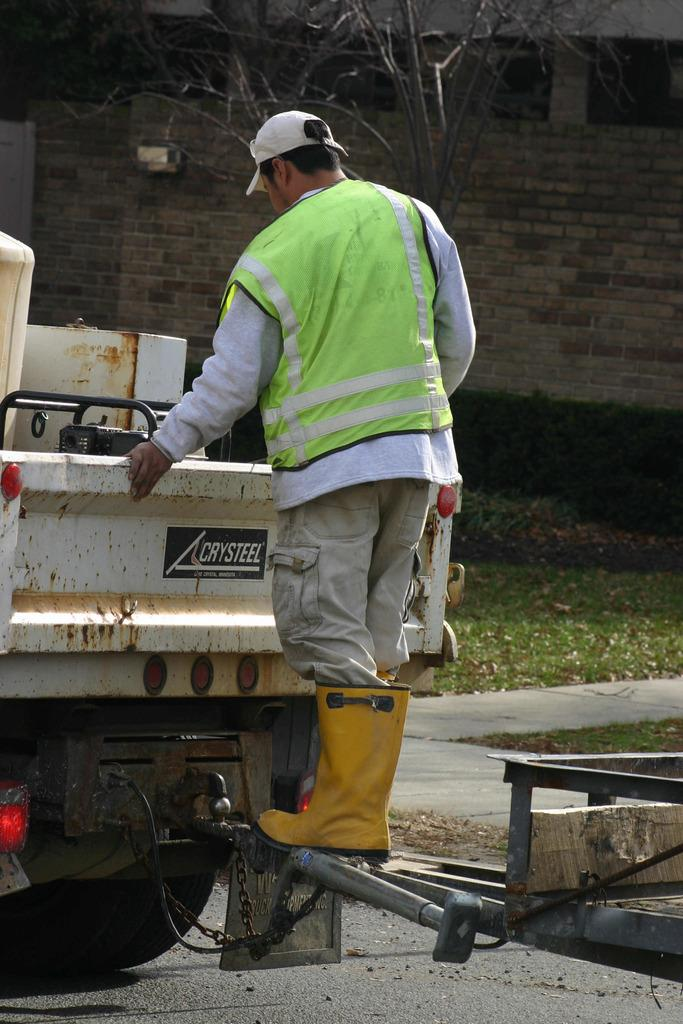What is the person in the image doing? The person is standing on a vehicle in the image. What is behind the person in the image? There is a wall of a building behind the person. What type of vegetation can be seen in the image? There is a tree visible in the image, and grass is present. What is visible at the bottom of the image? There is a road visible at the bottom of the image. What type of furniture can be seen in the image? There is no furniture present in the image. What role does the minister play in the image? There is no minister present in the image. 